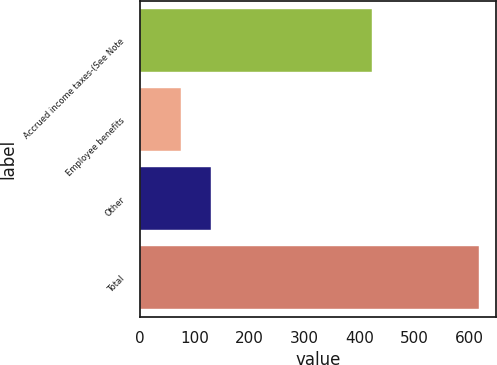Convert chart to OTSL. <chart><loc_0><loc_0><loc_500><loc_500><bar_chart><fcel>Accrued income taxes-(See Note<fcel>Employee benefits<fcel>Other<fcel>Total<nl><fcel>423<fcel>76<fcel>130.1<fcel>617<nl></chart> 